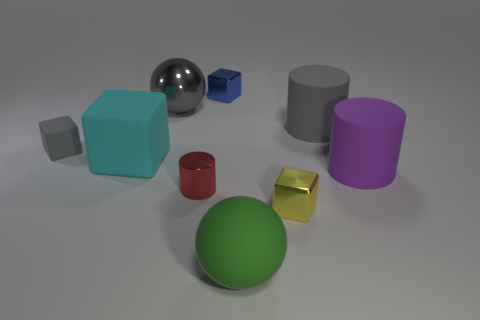Subtract all tiny metallic cylinders. How many cylinders are left? 2 Subtract 1 blocks. How many blocks are left? 3 Subtract all yellow blocks. How many blocks are left? 3 Subtract all brown blocks. Subtract all yellow cylinders. How many blocks are left? 4 Subtract all cubes. How many objects are left? 5 Add 1 big gray cylinders. How many objects exist? 10 Add 3 cylinders. How many cylinders exist? 6 Subtract 0 red cubes. How many objects are left? 9 Subtract all purple objects. Subtract all gray things. How many objects are left? 5 Add 5 large gray cylinders. How many large gray cylinders are left? 6 